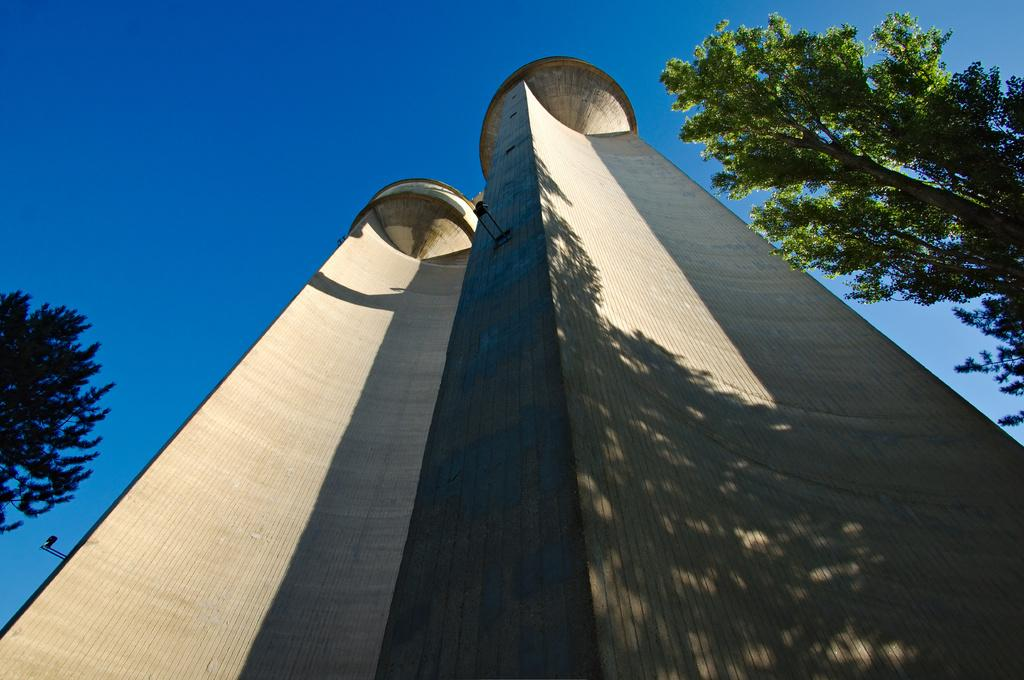What is the main structure in the image? There is a building in the image. What type of vegetation is present on either side of the building? There are trees on either side of the building. What is visible at the top of the image? The sky is visible at the top of the image. What type of spark can be seen coming from the building in the image? There is no spark present in the image; it only features a building, trees, and the sky. 